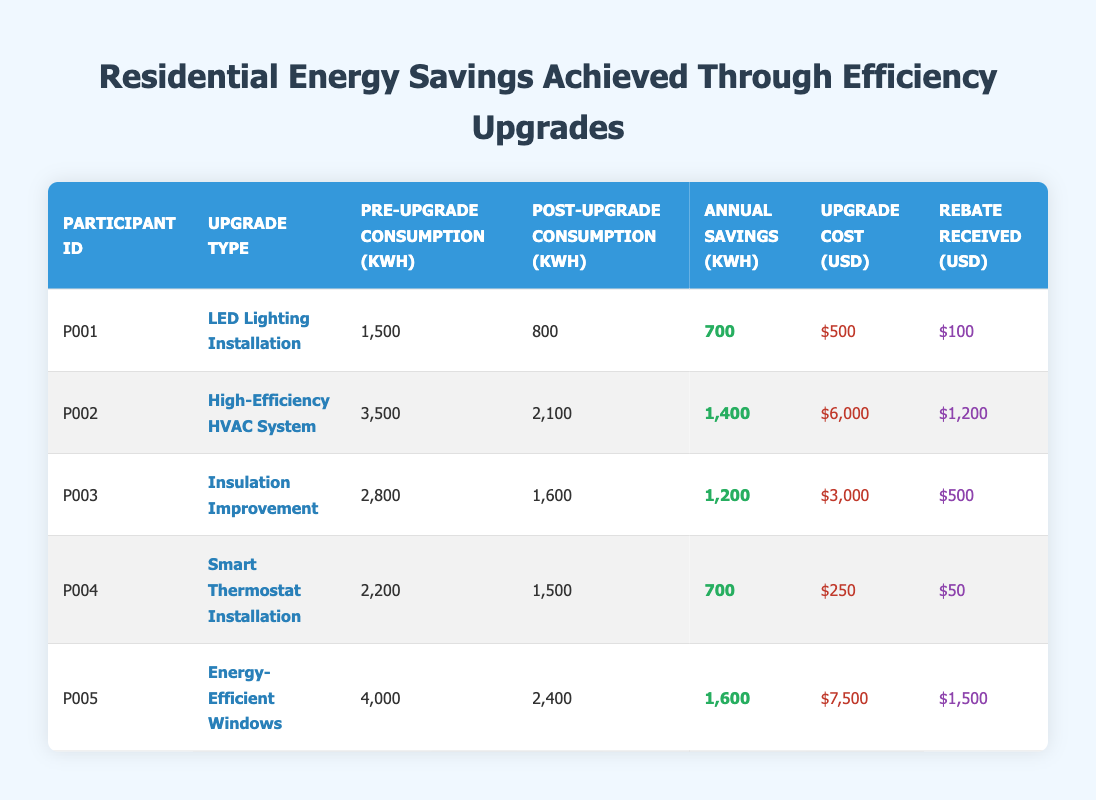What is the annual savings in kWh for participant P002? The table lists the data for each participant. To find the annual savings for participant P002, I can look under the "Annual Savings (kWh)" column corresponding to participant P002, which shows 1,400 kWh.
Answer: 1,400 kWh Which upgrade type resulted in the highest annual savings? By examining the "Annual Savings (kWh)" column of the table, I can compare all values. P005 has the highest at 1,600 kWh for the "Energy-Efficient Windows" upgrade.
Answer: Energy-Efficient Windows What is the total cost of upgrades for all participants? I need to sum the "Upgrade Cost (USD)" for all participants. The values are: 500 + 6000 + 3000 + 250 + 7500 = 10,250 USD.
Answer: 10,250 USD Did participant P001 receive a rebate of more than $100? Looking at the "Rebate Received (USD)" column, participant P001 received $100, which is not more than $100, hence the answer is no.
Answer: No What is the average annual savings across all participants? To find the average, I sum the annual savings for all participants: 700 + 1400 + 1200 + 700 + 1600 = 4100 kWh. There are 5 participants, so the average annual savings is 4100 / 5 = 820 kWh.
Answer: 820 kWh Which participant had the least pre-upgrade consumption? I look at the "Pre-Upgrade Consumption (kWh)" column and find the smallest value. P001 has the least at 1,500 kWh.
Answer: P001 How much rebate did participant P005 receive compared to the cost of the upgrade? Participant P005 received a rebate of $1,500 for an upgrade cost of $7,500. The rebate is 20% of the cost ($1,500 / $7,500 = 0.20).
Answer: 20% Was the post-upgrade consumption less than 1,500 kWh for all participants? I need to check the "Post-Upgrade Consumption (kWh)" for each participant. P001 (800), P002 (2,100), P003 (1,600), P004 (1,500), and P005 (2,400). Not all values are less than 1,500 kWh, so the answer is no.
Answer: No Which upgrade had the highest cost per kWh saved? First, I calculate the cost per kWh saved for each upgrade by dividing the "Cost of Upgrade (USD)" by "Annual Savings (kWh)". For P001, it's 500 / 700 = 0.71. For P002, it's 6000 / 1400 = 4.29. For P003, it's 3000 / 1200 = 2.5. For P004, it's 250 / 700 = 0.36. For P005, it's 7500 / 1600 = 4.69. The highest is 4.29 for P002.
Answer: High-Efficiency HVAC System 